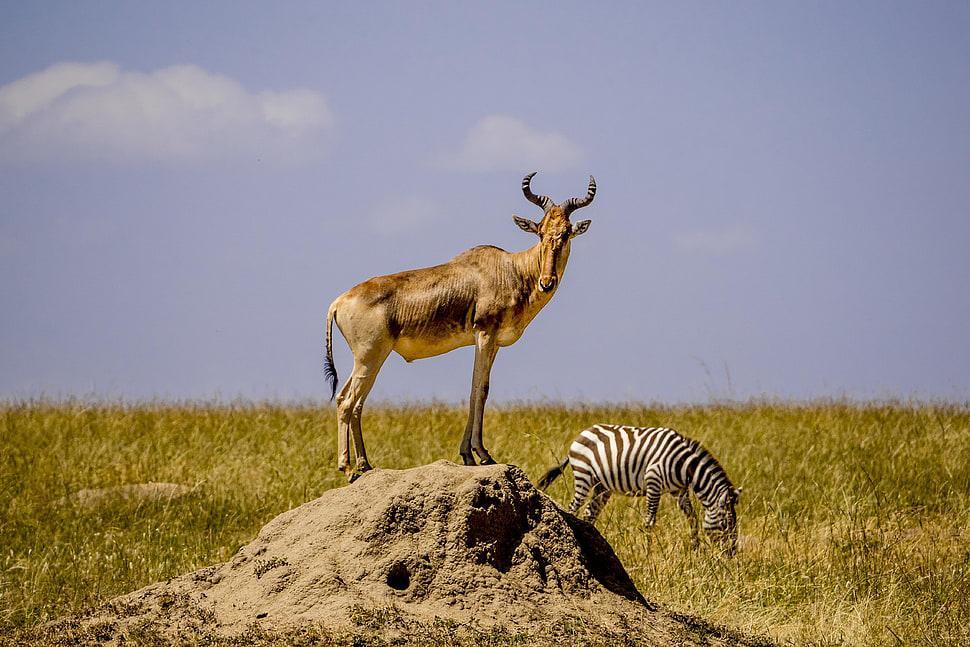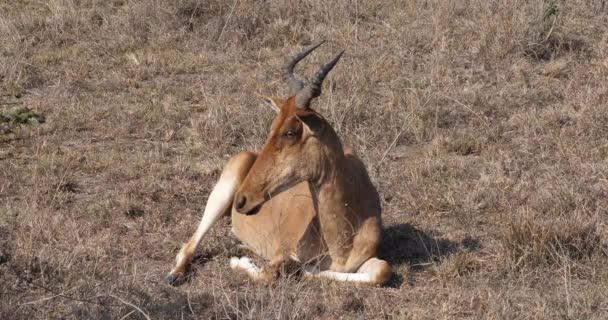The first image is the image on the left, the second image is the image on the right. Assess this claim about the two images: "Three horned animals in standing poses are in the image on the left.". Correct or not? Answer yes or no. No. The first image is the image on the left, the second image is the image on the right. Given the left and right images, does the statement "The left image contains at least three antelopes." hold true? Answer yes or no. No. 